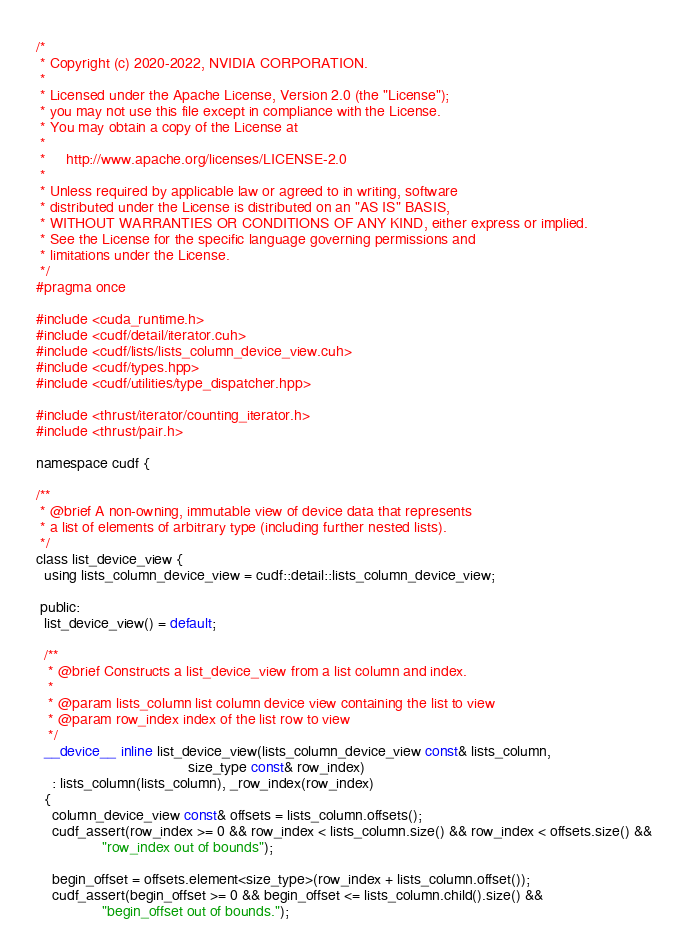Convert code to text. <code><loc_0><loc_0><loc_500><loc_500><_Cuda_>/*
 * Copyright (c) 2020-2022, NVIDIA CORPORATION.
 *
 * Licensed under the Apache License, Version 2.0 (the "License");
 * you may not use this file except in compliance with the License.
 * You may obtain a copy of the License at
 *
 *     http://www.apache.org/licenses/LICENSE-2.0
 *
 * Unless required by applicable law or agreed to in writing, software
 * distributed under the License is distributed on an "AS IS" BASIS,
 * WITHOUT WARRANTIES OR CONDITIONS OF ANY KIND, either express or implied.
 * See the License for the specific language governing permissions and
 * limitations under the License.
 */
#pragma once

#include <cuda_runtime.h>
#include <cudf/detail/iterator.cuh>
#include <cudf/lists/lists_column_device_view.cuh>
#include <cudf/types.hpp>
#include <cudf/utilities/type_dispatcher.hpp>

#include <thrust/iterator/counting_iterator.h>
#include <thrust/pair.h>

namespace cudf {

/**
 * @brief A non-owning, immutable view of device data that represents
 * a list of elements of arbitrary type (including further nested lists).
 */
class list_device_view {
  using lists_column_device_view = cudf::detail::lists_column_device_view;

 public:
  list_device_view() = default;

  /**
   * @brief Constructs a list_device_view from a list column and index.
   *
   * @param lists_column list column device view containing the list to view
   * @param row_index index of the list row to view
   */
  __device__ inline list_device_view(lists_column_device_view const& lists_column,
                                     size_type const& row_index)
    : lists_column(lists_column), _row_index(row_index)
  {
    column_device_view const& offsets = lists_column.offsets();
    cudf_assert(row_index >= 0 && row_index < lists_column.size() && row_index < offsets.size() &&
                "row_index out of bounds");

    begin_offset = offsets.element<size_type>(row_index + lists_column.offset());
    cudf_assert(begin_offset >= 0 && begin_offset <= lists_column.child().size() &&
                "begin_offset out of bounds.");</code> 